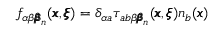<formula> <loc_0><loc_0><loc_500><loc_500>f _ { \alpha \beta { \pm b \beta } _ { n } } ( { \pm b x } , { \pm b \xi } ) = \delta _ { \alpha a } { \tau } _ { a b \beta { \pm b \beta } _ { n } } ( { \pm b x } , { \pm b \xi } ) n _ { b } ( { \pm b x } )</formula> 